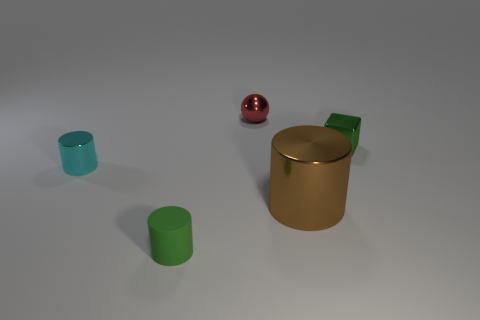There is a tiny object that is the same color as the shiny block; what shape is it?
Give a very brief answer. Cylinder. Do the small cyan shiny object and the brown shiny thing have the same shape?
Offer a terse response. Yes. The brown cylinder that is the same material as the tiny red object is what size?
Provide a short and direct response. Large. Is the number of green cubes less than the number of blue cylinders?
Your response must be concise. No. What number of tiny things are cyan metallic things or purple matte cylinders?
Your response must be concise. 1. How many tiny metal objects are both to the left of the metallic cube and right of the green rubber cylinder?
Provide a succinct answer. 1. Are there more tiny spheres than big green rubber blocks?
Keep it short and to the point. Yes. How many other things are the same shape as the small rubber object?
Ensure brevity in your answer.  2. Does the small rubber thing have the same color as the small block?
Give a very brief answer. Yes. What is the material of the cylinder that is both on the right side of the tiny cyan cylinder and left of the big shiny object?
Your answer should be compact. Rubber. 